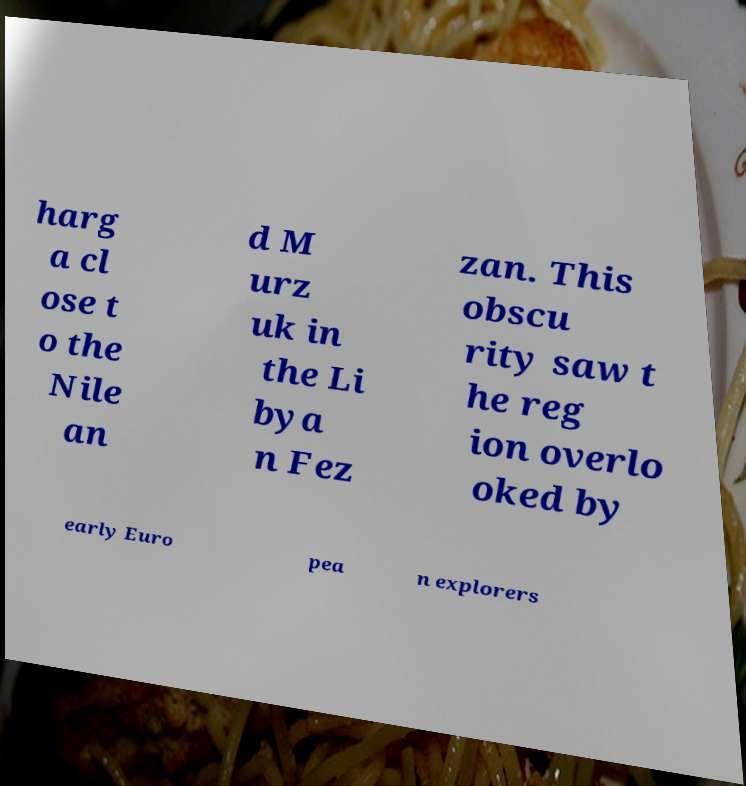Could you assist in decoding the text presented in this image and type it out clearly? harg a cl ose t o the Nile an d M urz uk in the Li bya n Fez zan. This obscu rity saw t he reg ion overlo oked by early Euro pea n explorers 